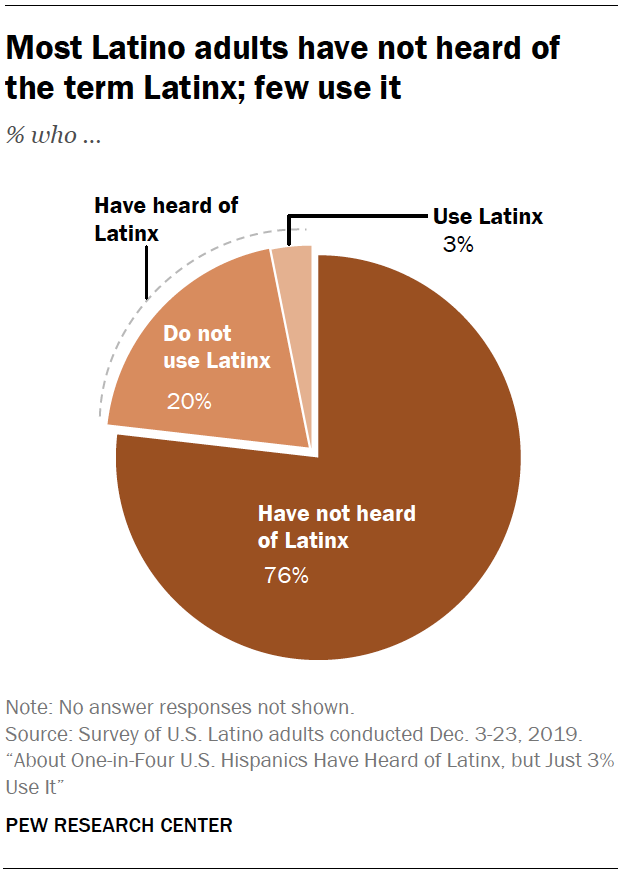Can you provide more context on the social implications of the term 'Latinx' as depicted in the chart? Certainly. The chart suggests that the term 'Latinx' is not widely embraced or recognized within the Latino community. This could indicate a cultural disconnect between the term and the self-identification preferences of the community. It may also reflect differences in opinion on gender-neutral terminology and its necessity or relevance in the Spanish language. 